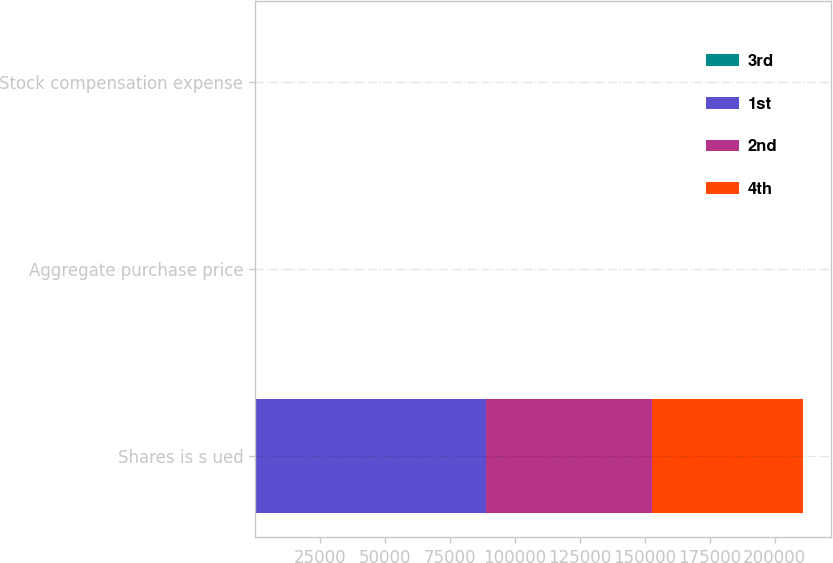Convert chart. <chart><loc_0><loc_0><loc_500><loc_500><stacked_bar_chart><ecel><fcel>Shares is s ued<fcel>Aggregate purchase price<fcel>Stock compensation expense<nl><fcel>3rd<fcel>1.3<fcel>2.4<fcel>0.6<nl><fcel>1st<fcel>89000<fcel>1.4<fcel>0.3<nl><fcel>2nd<fcel>64000<fcel>1.3<fcel>0.4<nl><fcel>4th<fcel>58000<fcel>1.3<fcel>0.3<nl></chart> 